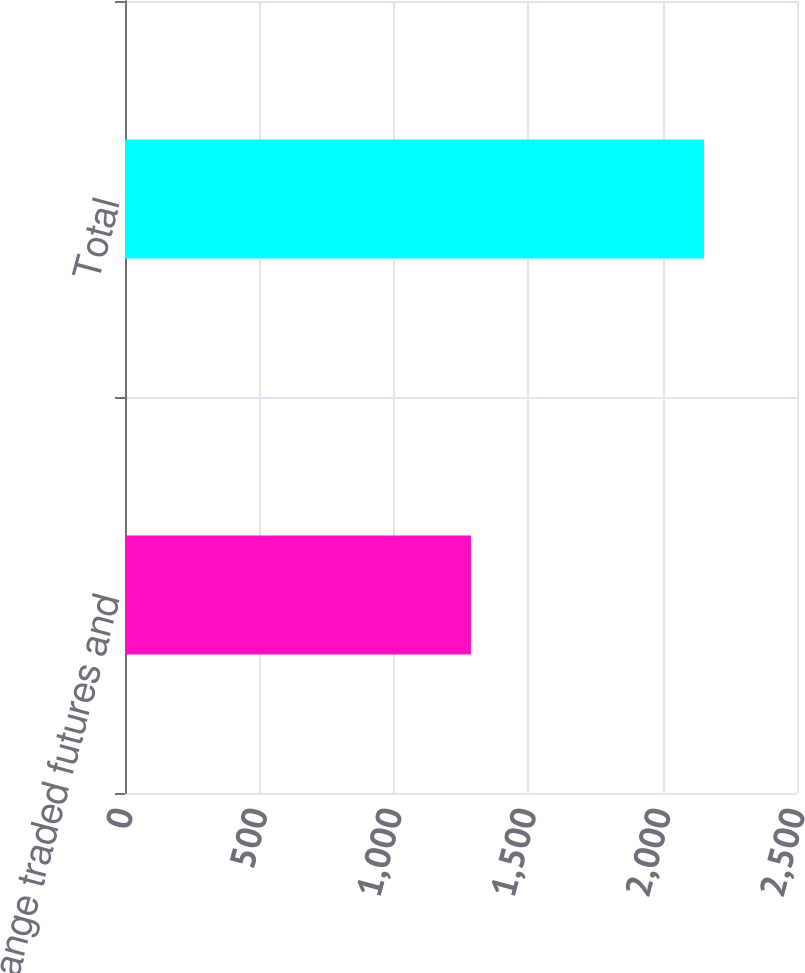Convert chart to OTSL. <chart><loc_0><loc_0><loc_500><loc_500><bar_chart><fcel>Exchange traded futures and<fcel>Total<nl><fcel>1287<fcel>2154<nl></chart> 